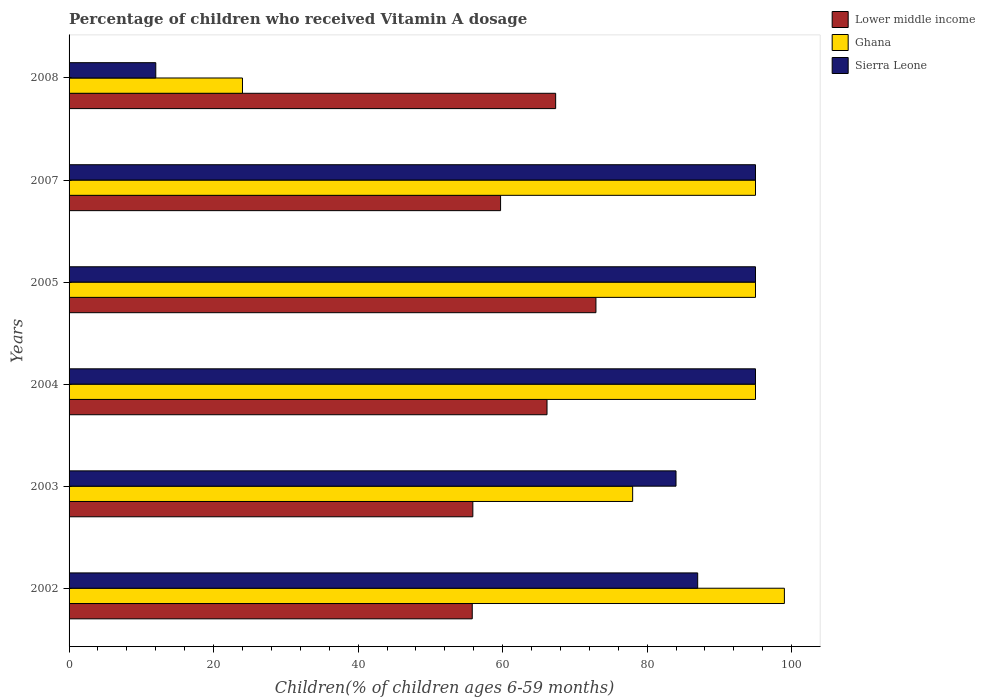Are the number of bars per tick equal to the number of legend labels?
Your answer should be very brief. Yes. Are the number of bars on each tick of the Y-axis equal?
Give a very brief answer. Yes. In how many cases, is the number of bars for a given year not equal to the number of legend labels?
Make the answer very short. 0. What is the percentage of children who received Vitamin A dosage in Lower middle income in 2005?
Offer a very short reply. 72.92. Across all years, what is the maximum percentage of children who received Vitamin A dosage in Ghana?
Your response must be concise. 99. Across all years, what is the minimum percentage of children who received Vitamin A dosage in Sierra Leone?
Your answer should be compact. 12. What is the total percentage of children who received Vitamin A dosage in Ghana in the graph?
Your answer should be compact. 486. What is the difference between the percentage of children who received Vitamin A dosage in Lower middle income in 2003 and that in 2008?
Provide a succinct answer. -11.46. What is the difference between the percentage of children who received Vitamin A dosage in Lower middle income in 2004 and the percentage of children who received Vitamin A dosage in Ghana in 2003?
Offer a very short reply. -11.85. What is the average percentage of children who received Vitamin A dosage in Ghana per year?
Keep it short and to the point. 81. In the year 2007, what is the difference between the percentage of children who received Vitamin A dosage in Lower middle income and percentage of children who received Vitamin A dosage in Ghana?
Your response must be concise. -35.28. What is the ratio of the percentage of children who received Vitamin A dosage in Lower middle income in 2002 to that in 2007?
Your answer should be very brief. 0.93. Is the percentage of children who received Vitamin A dosage in Lower middle income in 2002 less than that in 2007?
Give a very brief answer. Yes. Is the difference between the percentage of children who received Vitamin A dosage in Lower middle income in 2004 and 2007 greater than the difference between the percentage of children who received Vitamin A dosage in Ghana in 2004 and 2007?
Ensure brevity in your answer.  Yes. What is the difference between the highest and the second highest percentage of children who received Vitamin A dosage in Lower middle income?
Give a very brief answer. 5.57. In how many years, is the percentage of children who received Vitamin A dosage in Ghana greater than the average percentage of children who received Vitamin A dosage in Ghana taken over all years?
Make the answer very short. 4. Is the sum of the percentage of children who received Vitamin A dosage in Lower middle income in 2002 and 2003 greater than the maximum percentage of children who received Vitamin A dosage in Sierra Leone across all years?
Offer a terse response. Yes. What does the 3rd bar from the top in 2008 represents?
Provide a succinct answer. Lower middle income. What does the 3rd bar from the bottom in 2007 represents?
Keep it short and to the point. Sierra Leone. Is it the case that in every year, the sum of the percentage of children who received Vitamin A dosage in Lower middle income and percentage of children who received Vitamin A dosage in Ghana is greater than the percentage of children who received Vitamin A dosage in Sierra Leone?
Provide a short and direct response. Yes. Are all the bars in the graph horizontal?
Keep it short and to the point. Yes. What is the difference between two consecutive major ticks on the X-axis?
Keep it short and to the point. 20. Are the values on the major ticks of X-axis written in scientific E-notation?
Offer a very short reply. No. Does the graph contain grids?
Provide a short and direct response. No. What is the title of the graph?
Your response must be concise. Percentage of children who received Vitamin A dosage. Does "Slovenia" appear as one of the legend labels in the graph?
Keep it short and to the point. No. What is the label or title of the X-axis?
Make the answer very short. Children(% of children ages 6-59 months). What is the label or title of the Y-axis?
Provide a succinct answer. Years. What is the Children(% of children ages 6-59 months) in Lower middle income in 2002?
Offer a terse response. 55.8. What is the Children(% of children ages 6-59 months) in Lower middle income in 2003?
Keep it short and to the point. 55.88. What is the Children(% of children ages 6-59 months) of Sierra Leone in 2003?
Give a very brief answer. 84. What is the Children(% of children ages 6-59 months) of Lower middle income in 2004?
Provide a short and direct response. 66.15. What is the Children(% of children ages 6-59 months) of Ghana in 2004?
Make the answer very short. 95. What is the Children(% of children ages 6-59 months) in Lower middle income in 2005?
Your response must be concise. 72.92. What is the Children(% of children ages 6-59 months) of Ghana in 2005?
Give a very brief answer. 95. What is the Children(% of children ages 6-59 months) in Sierra Leone in 2005?
Ensure brevity in your answer.  95. What is the Children(% of children ages 6-59 months) of Lower middle income in 2007?
Provide a succinct answer. 59.72. What is the Children(% of children ages 6-59 months) in Ghana in 2007?
Ensure brevity in your answer.  95. What is the Children(% of children ages 6-59 months) of Lower middle income in 2008?
Your answer should be compact. 67.34. Across all years, what is the maximum Children(% of children ages 6-59 months) of Lower middle income?
Make the answer very short. 72.92. Across all years, what is the maximum Children(% of children ages 6-59 months) of Ghana?
Keep it short and to the point. 99. Across all years, what is the maximum Children(% of children ages 6-59 months) of Sierra Leone?
Provide a succinct answer. 95. Across all years, what is the minimum Children(% of children ages 6-59 months) in Lower middle income?
Ensure brevity in your answer.  55.8. Across all years, what is the minimum Children(% of children ages 6-59 months) in Ghana?
Your answer should be compact. 24. Across all years, what is the minimum Children(% of children ages 6-59 months) of Sierra Leone?
Provide a short and direct response. 12. What is the total Children(% of children ages 6-59 months) of Lower middle income in the graph?
Your answer should be compact. 377.81. What is the total Children(% of children ages 6-59 months) in Ghana in the graph?
Make the answer very short. 486. What is the total Children(% of children ages 6-59 months) of Sierra Leone in the graph?
Make the answer very short. 468. What is the difference between the Children(% of children ages 6-59 months) of Lower middle income in 2002 and that in 2003?
Keep it short and to the point. -0.08. What is the difference between the Children(% of children ages 6-59 months) of Sierra Leone in 2002 and that in 2003?
Provide a short and direct response. 3. What is the difference between the Children(% of children ages 6-59 months) of Lower middle income in 2002 and that in 2004?
Make the answer very short. -10.35. What is the difference between the Children(% of children ages 6-59 months) of Lower middle income in 2002 and that in 2005?
Your answer should be compact. -17.12. What is the difference between the Children(% of children ages 6-59 months) in Ghana in 2002 and that in 2005?
Provide a short and direct response. 4. What is the difference between the Children(% of children ages 6-59 months) in Lower middle income in 2002 and that in 2007?
Your response must be concise. -3.92. What is the difference between the Children(% of children ages 6-59 months) of Sierra Leone in 2002 and that in 2007?
Offer a very short reply. -8. What is the difference between the Children(% of children ages 6-59 months) in Lower middle income in 2002 and that in 2008?
Keep it short and to the point. -11.54. What is the difference between the Children(% of children ages 6-59 months) of Ghana in 2002 and that in 2008?
Your answer should be compact. 75. What is the difference between the Children(% of children ages 6-59 months) in Sierra Leone in 2002 and that in 2008?
Keep it short and to the point. 75. What is the difference between the Children(% of children ages 6-59 months) of Lower middle income in 2003 and that in 2004?
Offer a very short reply. -10.27. What is the difference between the Children(% of children ages 6-59 months) in Ghana in 2003 and that in 2004?
Keep it short and to the point. -17. What is the difference between the Children(% of children ages 6-59 months) of Lower middle income in 2003 and that in 2005?
Your answer should be very brief. -17.04. What is the difference between the Children(% of children ages 6-59 months) in Ghana in 2003 and that in 2005?
Your answer should be compact. -17. What is the difference between the Children(% of children ages 6-59 months) of Lower middle income in 2003 and that in 2007?
Your answer should be compact. -3.84. What is the difference between the Children(% of children ages 6-59 months) in Lower middle income in 2003 and that in 2008?
Provide a short and direct response. -11.46. What is the difference between the Children(% of children ages 6-59 months) of Ghana in 2003 and that in 2008?
Give a very brief answer. 54. What is the difference between the Children(% of children ages 6-59 months) in Sierra Leone in 2003 and that in 2008?
Ensure brevity in your answer.  72. What is the difference between the Children(% of children ages 6-59 months) in Lower middle income in 2004 and that in 2005?
Your answer should be very brief. -6.77. What is the difference between the Children(% of children ages 6-59 months) of Sierra Leone in 2004 and that in 2005?
Make the answer very short. 0. What is the difference between the Children(% of children ages 6-59 months) in Lower middle income in 2004 and that in 2007?
Your answer should be very brief. 6.43. What is the difference between the Children(% of children ages 6-59 months) of Lower middle income in 2004 and that in 2008?
Your answer should be very brief. -1.2. What is the difference between the Children(% of children ages 6-59 months) of Ghana in 2004 and that in 2008?
Give a very brief answer. 71. What is the difference between the Children(% of children ages 6-59 months) in Sierra Leone in 2004 and that in 2008?
Your response must be concise. 83. What is the difference between the Children(% of children ages 6-59 months) in Lower middle income in 2005 and that in 2007?
Make the answer very short. 13.2. What is the difference between the Children(% of children ages 6-59 months) of Lower middle income in 2005 and that in 2008?
Offer a very short reply. 5.57. What is the difference between the Children(% of children ages 6-59 months) of Sierra Leone in 2005 and that in 2008?
Ensure brevity in your answer.  83. What is the difference between the Children(% of children ages 6-59 months) in Lower middle income in 2007 and that in 2008?
Keep it short and to the point. -7.62. What is the difference between the Children(% of children ages 6-59 months) in Sierra Leone in 2007 and that in 2008?
Your response must be concise. 83. What is the difference between the Children(% of children ages 6-59 months) in Lower middle income in 2002 and the Children(% of children ages 6-59 months) in Ghana in 2003?
Provide a succinct answer. -22.2. What is the difference between the Children(% of children ages 6-59 months) in Lower middle income in 2002 and the Children(% of children ages 6-59 months) in Sierra Leone in 2003?
Your response must be concise. -28.2. What is the difference between the Children(% of children ages 6-59 months) in Ghana in 2002 and the Children(% of children ages 6-59 months) in Sierra Leone in 2003?
Offer a very short reply. 15. What is the difference between the Children(% of children ages 6-59 months) of Lower middle income in 2002 and the Children(% of children ages 6-59 months) of Ghana in 2004?
Keep it short and to the point. -39.2. What is the difference between the Children(% of children ages 6-59 months) of Lower middle income in 2002 and the Children(% of children ages 6-59 months) of Sierra Leone in 2004?
Give a very brief answer. -39.2. What is the difference between the Children(% of children ages 6-59 months) of Ghana in 2002 and the Children(% of children ages 6-59 months) of Sierra Leone in 2004?
Your answer should be very brief. 4. What is the difference between the Children(% of children ages 6-59 months) of Lower middle income in 2002 and the Children(% of children ages 6-59 months) of Ghana in 2005?
Make the answer very short. -39.2. What is the difference between the Children(% of children ages 6-59 months) of Lower middle income in 2002 and the Children(% of children ages 6-59 months) of Sierra Leone in 2005?
Provide a succinct answer. -39.2. What is the difference between the Children(% of children ages 6-59 months) in Lower middle income in 2002 and the Children(% of children ages 6-59 months) in Ghana in 2007?
Make the answer very short. -39.2. What is the difference between the Children(% of children ages 6-59 months) of Lower middle income in 2002 and the Children(% of children ages 6-59 months) of Sierra Leone in 2007?
Offer a terse response. -39.2. What is the difference between the Children(% of children ages 6-59 months) of Ghana in 2002 and the Children(% of children ages 6-59 months) of Sierra Leone in 2007?
Provide a short and direct response. 4. What is the difference between the Children(% of children ages 6-59 months) in Lower middle income in 2002 and the Children(% of children ages 6-59 months) in Ghana in 2008?
Offer a very short reply. 31.8. What is the difference between the Children(% of children ages 6-59 months) in Lower middle income in 2002 and the Children(% of children ages 6-59 months) in Sierra Leone in 2008?
Offer a terse response. 43.8. What is the difference between the Children(% of children ages 6-59 months) in Lower middle income in 2003 and the Children(% of children ages 6-59 months) in Ghana in 2004?
Your answer should be compact. -39.12. What is the difference between the Children(% of children ages 6-59 months) of Lower middle income in 2003 and the Children(% of children ages 6-59 months) of Sierra Leone in 2004?
Offer a very short reply. -39.12. What is the difference between the Children(% of children ages 6-59 months) in Ghana in 2003 and the Children(% of children ages 6-59 months) in Sierra Leone in 2004?
Ensure brevity in your answer.  -17. What is the difference between the Children(% of children ages 6-59 months) of Lower middle income in 2003 and the Children(% of children ages 6-59 months) of Ghana in 2005?
Offer a terse response. -39.12. What is the difference between the Children(% of children ages 6-59 months) in Lower middle income in 2003 and the Children(% of children ages 6-59 months) in Sierra Leone in 2005?
Provide a short and direct response. -39.12. What is the difference between the Children(% of children ages 6-59 months) in Ghana in 2003 and the Children(% of children ages 6-59 months) in Sierra Leone in 2005?
Your answer should be compact. -17. What is the difference between the Children(% of children ages 6-59 months) in Lower middle income in 2003 and the Children(% of children ages 6-59 months) in Ghana in 2007?
Your answer should be compact. -39.12. What is the difference between the Children(% of children ages 6-59 months) of Lower middle income in 2003 and the Children(% of children ages 6-59 months) of Sierra Leone in 2007?
Make the answer very short. -39.12. What is the difference between the Children(% of children ages 6-59 months) in Ghana in 2003 and the Children(% of children ages 6-59 months) in Sierra Leone in 2007?
Give a very brief answer. -17. What is the difference between the Children(% of children ages 6-59 months) in Lower middle income in 2003 and the Children(% of children ages 6-59 months) in Ghana in 2008?
Give a very brief answer. 31.88. What is the difference between the Children(% of children ages 6-59 months) in Lower middle income in 2003 and the Children(% of children ages 6-59 months) in Sierra Leone in 2008?
Your response must be concise. 43.88. What is the difference between the Children(% of children ages 6-59 months) of Ghana in 2003 and the Children(% of children ages 6-59 months) of Sierra Leone in 2008?
Provide a succinct answer. 66. What is the difference between the Children(% of children ages 6-59 months) of Lower middle income in 2004 and the Children(% of children ages 6-59 months) of Ghana in 2005?
Give a very brief answer. -28.85. What is the difference between the Children(% of children ages 6-59 months) of Lower middle income in 2004 and the Children(% of children ages 6-59 months) of Sierra Leone in 2005?
Your answer should be compact. -28.85. What is the difference between the Children(% of children ages 6-59 months) of Lower middle income in 2004 and the Children(% of children ages 6-59 months) of Ghana in 2007?
Keep it short and to the point. -28.85. What is the difference between the Children(% of children ages 6-59 months) in Lower middle income in 2004 and the Children(% of children ages 6-59 months) in Sierra Leone in 2007?
Your response must be concise. -28.85. What is the difference between the Children(% of children ages 6-59 months) in Ghana in 2004 and the Children(% of children ages 6-59 months) in Sierra Leone in 2007?
Your response must be concise. 0. What is the difference between the Children(% of children ages 6-59 months) in Lower middle income in 2004 and the Children(% of children ages 6-59 months) in Ghana in 2008?
Your response must be concise. 42.15. What is the difference between the Children(% of children ages 6-59 months) of Lower middle income in 2004 and the Children(% of children ages 6-59 months) of Sierra Leone in 2008?
Make the answer very short. 54.15. What is the difference between the Children(% of children ages 6-59 months) in Lower middle income in 2005 and the Children(% of children ages 6-59 months) in Ghana in 2007?
Offer a very short reply. -22.08. What is the difference between the Children(% of children ages 6-59 months) of Lower middle income in 2005 and the Children(% of children ages 6-59 months) of Sierra Leone in 2007?
Your response must be concise. -22.08. What is the difference between the Children(% of children ages 6-59 months) in Lower middle income in 2005 and the Children(% of children ages 6-59 months) in Ghana in 2008?
Give a very brief answer. 48.92. What is the difference between the Children(% of children ages 6-59 months) of Lower middle income in 2005 and the Children(% of children ages 6-59 months) of Sierra Leone in 2008?
Make the answer very short. 60.92. What is the difference between the Children(% of children ages 6-59 months) in Lower middle income in 2007 and the Children(% of children ages 6-59 months) in Ghana in 2008?
Make the answer very short. 35.72. What is the difference between the Children(% of children ages 6-59 months) in Lower middle income in 2007 and the Children(% of children ages 6-59 months) in Sierra Leone in 2008?
Provide a short and direct response. 47.72. What is the average Children(% of children ages 6-59 months) of Lower middle income per year?
Give a very brief answer. 62.97. In the year 2002, what is the difference between the Children(% of children ages 6-59 months) of Lower middle income and Children(% of children ages 6-59 months) of Ghana?
Offer a very short reply. -43.2. In the year 2002, what is the difference between the Children(% of children ages 6-59 months) in Lower middle income and Children(% of children ages 6-59 months) in Sierra Leone?
Offer a very short reply. -31.2. In the year 2003, what is the difference between the Children(% of children ages 6-59 months) of Lower middle income and Children(% of children ages 6-59 months) of Ghana?
Your response must be concise. -22.12. In the year 2003, what is the difference between the Children(% of children ages 6-59 months) in Lower middle income and Children(% of children ages 6-59 months) in Sierra Leone?
Ensure brevity in your answer.  -28.12. In the year 2003, what is the difference between the Children(% of children ages 6-59 months) of Ghana and Children(% of children ages 6-59 months) of Sierra Leone?
Offer a terse response. -6. In the year 2004, what is the difference between the Children(% of children ages 6-59 months) of Lower middle income and Children(% of children ages 6-59 months) of Ghana?
Make the answer very short. -28.85. In the year 2004, what is the difference between the Children(% of children ages 6-59 months) in Lower middle income and Children(% of children ages 6-59 months) in Sierra Leone?
Provide a short and direct response. -28.85. In the year 2005, what is the difference between the Children(% of children ages 6-59 months) of Lower middle income and Children(% of children ages 6-59 months) of Ghana?
Your answer should be very brief. -22.08. In the year 2005, what is the difference between the Children(% of children ages 6-59 months) of Lower middle income and Children(% of children ages 6-59 months) of Sierra Leone?
Offer a very short reply. -22.08. In the year 2005, what is the difference between the Children(% of children ages 6-59 months) in Ghana and Children(% of children ages 6-59 months) in Sierra Leone?
Your answer should be very brief. 0. In the year 2007, what is the difference between the Children(% of children ages 6-59 months) of Lower middle income and Children(% of children ages 6-59 months) of Ghana?
Give a very brief answer. -35.28. In the year 2007, what is the difference between the Children(% of children ages 6-59 months) in Lower middle income and Children(% of children ages 6-59 months) in Sierra Leone?
Your response must be concise. -35.28. In the year 2007, what is the difference between the Children(% of children ages 6-59 months) in Ghana and Children(% of children ages 6-59 months) in Sierra Leone?
Your response must be concise. 0. In the year 2008, what is the difference between the Children(% of children ages 6-59 months) of Lower middle income and Children(% of children ages 6-59 months) of Ghana?
Your answer should be very brief. 43.34. In the year 2008, what is the difference between the Children(% of children ages 6-59 months) in Lower middle income and Children(% of children ages 6-59 months) in Sierra Leone?
Provide a succinct answer. 55.34. In the year 2008, what is the difference between the Children(% of children ages 6-59 months) of Ghana and Children(% of children ages 6-59 months) of Sierra Leone?
Make the answer very short. 12. What is the ratio of the Children(% of children ages 6-59 months) of Ghana in 2002 to that in 2003?
Offer a very short reply. 1.27. What is the ratio of the Children(% of children ages 6-59 months) in Sierra Leone in 2002 to that in 2003?
Give a very brief answer. 1.04. What is the ratio of the Children(% of children ages 6-59 months) of Lower middle income in 2002 to that in 2004?
Provide a short and direct response. 0.84. What is the ratio of the Children(% of children ages 6-59 months) of Ghana in 2002 to that in 2004?
Give a very brief answer. 1.04. What is the ratio of the Children(% of children ages 6-59 months) of Sierra Leone in 2002 to that in 2004?
Ensure brevity in your answer.  0.92. What is the ratio of the Children(% of children ages 6-59 months) of Lower middle income in 2002 to that in 2005?
Your answer should be very brief. 0.77. What is the ratio of the Children(% of children ages 6-59 months) in Ghana in 2002 to that in 2005?
Offer a very short reply. 1.04. What is the ratio of the Children(% of children ages 6-59 months) of Sierra Leone in 2002 to that in 2005?
Offer a terse response. 0.92. What is the ratio of the Children(% of children ages 6-59 months) of Lower middle income in 2002 to that in 2007?
Ensure brevity in your answer.  0.93. What is the ratio of the Children(% of children ages 6-59 months) of Ghana in 2002 to that in 2007?
Keep it short and to the point. 1.04. What is the ratio of the Children(% of children ages 6-59 months) in Sierra Leone in 2002 to that in 2007?
Make the answer very short. 0.92. What is the ratio of the Children(% of children ages 6-59 months) of Lower middle income in 2002 to that in 2008?
Ensure brevity in your answer.  0.83. What is the ratio of the Children(% of children ages 6-59 months) in Ghana in 2002 to that in 2008?
Your response must be concise. 4.12. What is the ratio of the Children(% of children ages 6-59 months) of Sierra Leone in 2002 to that in 2008?
Your answer should be very brief. 7.25. What is the ratio of the Children(% of children ages 6-59 months) of Lower middle income in 2003 to that in 2004?
Offer a terse response. 0.84. What is the ratio of the Children(% of children ages 6-59 months) of Ghana in 2003 to that in 2004?
Give a very brief answer. 0.82. What is the ratio of the Children(% of children ages 6-59 months) of Sierra Leone in 2003 to that in 2004?
Your answer should be very brief. 0.88. What is the ratio of the Children(% of children ages 6-59 months) of Lower middle income in 2003 to that in 2005?
Give a very brief answer. 0.77. What is the ratio of the Children(% of children ages 6-59 months) in Ghana in 2003 to that in 2005?
Provide a short and direct response. 0.82. What is the ratio of the Children(% of children ages 6-59 months) of Sierra Leone in 2003 to that in 2005?
Your answer should be very brief. 0.88. What is the ratio of the Children(% of children ages 6-59 months) in Lower middle income in 2003 to that in 2007?
Your response must be concise. 0.94. What is the ratio of the Children(% of children ages 6-59 months) in Ghana in 2003 to that in 2007?
Keep it short and to the point. 0.82. What is the ratio of the Children(% of children ages 6-59 months) in Sierra Leone in 2003 to that in 2007?
Provide a short and direct response. 0.88. What is the ratio of the Children(% of children ages 6-59 months) of Lower middle income in 2003 to that in 2008?
Offer a very short reply. 0.83. What is the ratio of the Children(% of children ages 6-59 months) in Sierra Leone in 2003 to that in 2008?
Your answer should be compact. 7. What is the ratio of the Children(% of children ages 6-59 months) of Lower middle income in 2004 to that in 2005?
Offer a very short reply. 0.91. What is the ratio of the Children(% of children ages 6-59 months) in Lower middle income in 2004 to that in 2007?
Keep it short and to the point. 1.11. What is the ratio of the Children(% of children ages 6-59 months) in Sierra Leone in 2004 to that in 2007?
Offer a terse response. 1. What is the ratio of the Children(% of children ages 6-59 months) in Lower middle income in 2004 to that in 2008?
Your answer should be compact. 0.98. What is the ratio of the Children(% of children ages 6-59 months) in Ghana in 2004 to that in 2008?
Give a very brief answer. 3.96. What is the ratio of the Children(% of children ages 6-59 months) of Sierra Leone in 2004 to that in 2008?
Make the answer very short. 7.92. What is the ratio of the Children(% of children ages 6-59 months) in Lower middle income in 2005 to that in 2007?
Give a very brief answer. 1.22. What is the ratio of the Children(% of children ages 6-59 months) of Sierra Leone in 2005 to that in 2007?
Your answer should be very brief. 1. What is the ratio of the Children(% of children ages 6-59 months) in Lower middle income in 2005 to that in 2008?
Offer a very short reply. 1.08. What is the ratio of the Children(% of children ages 6-59 months) in Ghana in 2005 to that in 2008?
Offer a very short reply. 3.96. What is the ratio of the Children(% of children ages 6-59 months) of Sierra Leone in 2005 to that in 2008?
Your answer should be compact. 7.92. What is the ratio of the Children(% of children ages 6-59 months) in Lower middle income in 2007 to that in 2008?
Provide a short and direct response. 0.89. What is the ratio of the Children(% of children ages 6-59 months) in Ghana in 2007 to that in 2008?
Ensure brevity in your answer.  3.96. What is the ratio of the Children(% of children ages 6-59 months) in Sierra Leone in 2007 to that in 2008?
Keep it short and to the point. 7.92. What is the difference between the highest and the second highest Children(% of children ages 6-59 months) of Lower middle income?
Offer a terse response. 5.57. What is the difference between the highest and the second highest Children(% of children ages 6-59 months) in Ghana?
Keep it short and to the point. 4. What is the difference between the highest and the lowest Children(% of children ages 6-59 months) in Lower middle income?
Keep it short and to the point. 17.12. What is the difference between the highest and the lowest Children(% of children ages 6-59 months) in Sierra Leone?
Your response must be concise. 83. 